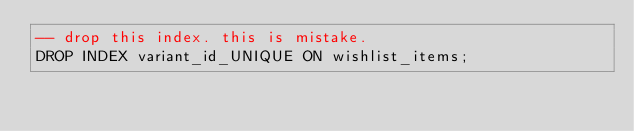Convert code to text. <code><loc_0><loc_0><loc_500><loc_500><_SQL_>-- drop this index. this is mistake.
DROP INDEX variant_id_UNIQUE ON wishlist_items;
</code> 